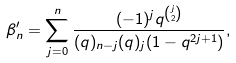<formula> <loc_0><loc_0><loc_500><loc_500>\beta ^ { \prime } _ { n } = \sum _ { j = 0 } ^ { n } \frac { ( - 1 ) ^ { j } q ^ { \binom { j } { 2 } } } { ( q ) _ { n - j } ( q ) _ { j } ( 1 - q ^ { 2 j + 1 } ) } ,</formula> 